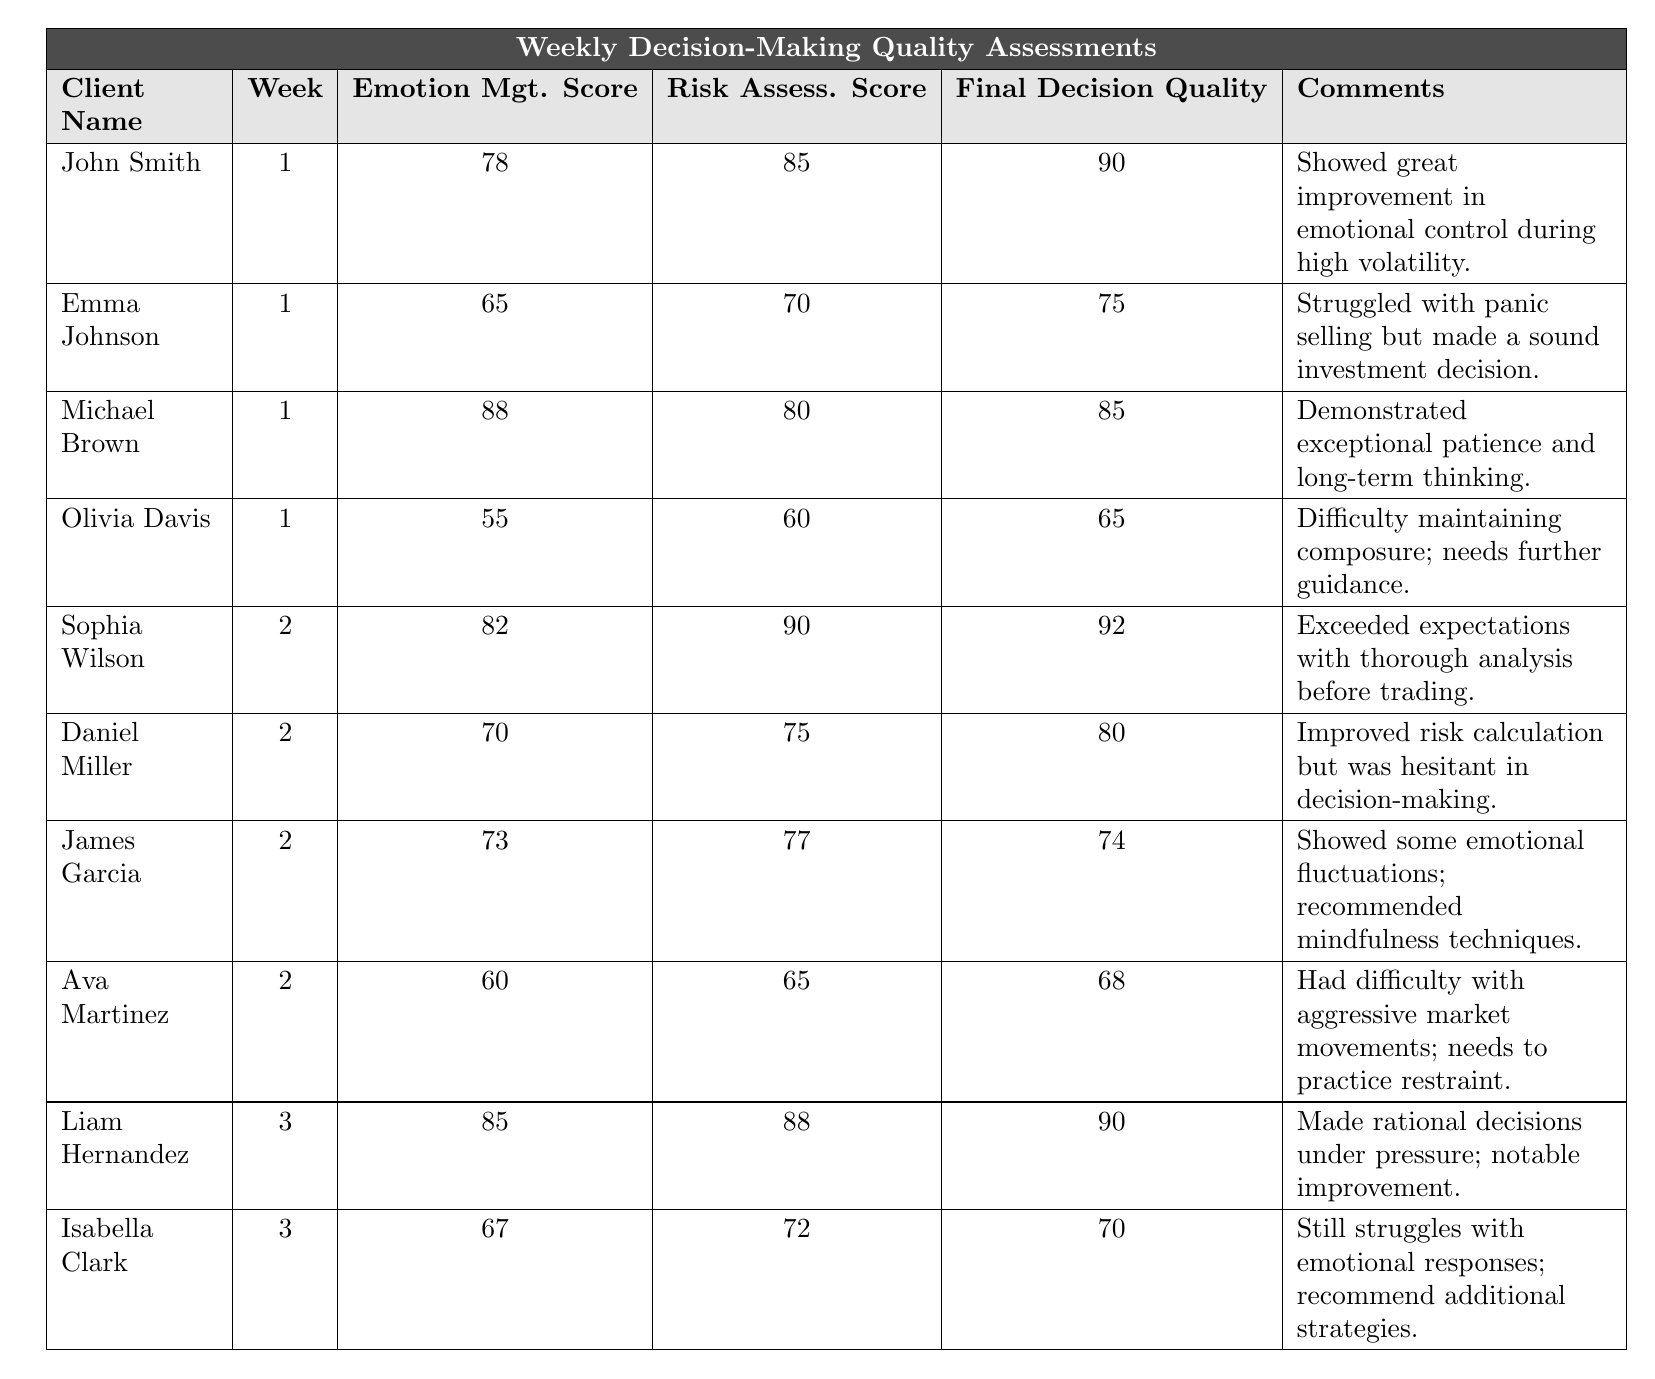What is the emotion management score of John Smith in week 1? The table shows the row for John Smith under week 1. The emotion management score listed is 78.
Answer: 78 What was the highest final decision quality score recorded in the table? By reviewing the final decision quality column, the highest value is 92, recorded for Sophia Wilson in week 2.
Answer: 92 Who had the lowest emotion management score in week 1? In week 1, Olivia Davis has the lowest emotion management score of 55, which can be found in her row of the table.
Answer: Olivia Davis What is the average risk assessment score for clients in week 2? The risk assessment scores for week 2 are 90, 75, 77, and 65. Summing these gives 90 + 75 + 77 + 65 = 307. There are 4 clients, so the average is 307 / 4 = 76.75.
Answer: 76.75 Did Michael Brown demonstrate better decision-making skills than Emma Johnson in week 1? Comparing the final decision quality scores for both clients, Michael Brown scored 85 while Emma Johnson scored 75, indicating that Michael Brown had better decision-making skills.
Answer: Yes How many clients improved their final decision quality from week 1 to week 2? Comparing the final decision qualities: John Smith (90), Emma Johnson (75), Michael Brown (85), Olivia Davis (65) in week 1, and Sophia Wilson (92), Daniel Miller (80), James Garcia (74), Ava Martinez (68) in week 2, only Michael Brown and Emma Johnson did not improve. Therefore, 6 clients improved.
Answer: 6 Which client had the highest risk assessment score across all weeks? The risk assessment scores are 85 (John Smith), 70 (Emma Johnson), 80 (Michael Brown), 60 (Olivia Davis), 90 (Sophia Wilson), 75 (Daniel Miller), 77 (James Garcia), 65 (Ava Martinez), 88 (Liam Hernandez), and 72 (Isabella Clark). The highest score is 90 for Sophia Wilson.
Answer: Sophia Wilson What strategy was recommended for James Garcia based on his performance? The comments state that James Garcia showed some emotional fluctuations, and mindfulness techniques were recommended.
Answer: Mindfulness techniques Compare the emotion management scores of Liam Hernandez and Isabella Clark in week 3. Who performed better? Liam Hernandez had an emotion management score of 85, while Isabella Clark scored 67 in week 3. Hence, Liam performed better.
Answer: Liam Hernandez How many total clients were assessed in week 1? The table lists 4 clients assessed in week 1: John Smith, Emma Johnson, Michael Brown, and Olivia Davis.
Answer: 4 What trend can be observed in emotion management from week 1 to week 3? The average emotion management scores increased: week 1 average = (78 + 65 + 88 + 55) / 4 = 71.5; week 2 average = (82 + 70 + 73 + 60) / 4 = 71.25; week 3 average = (85 + 67) / 2 = 76. So, the trend shows a general increase in week 3 compared to previous weeks.
Answer: Increase 